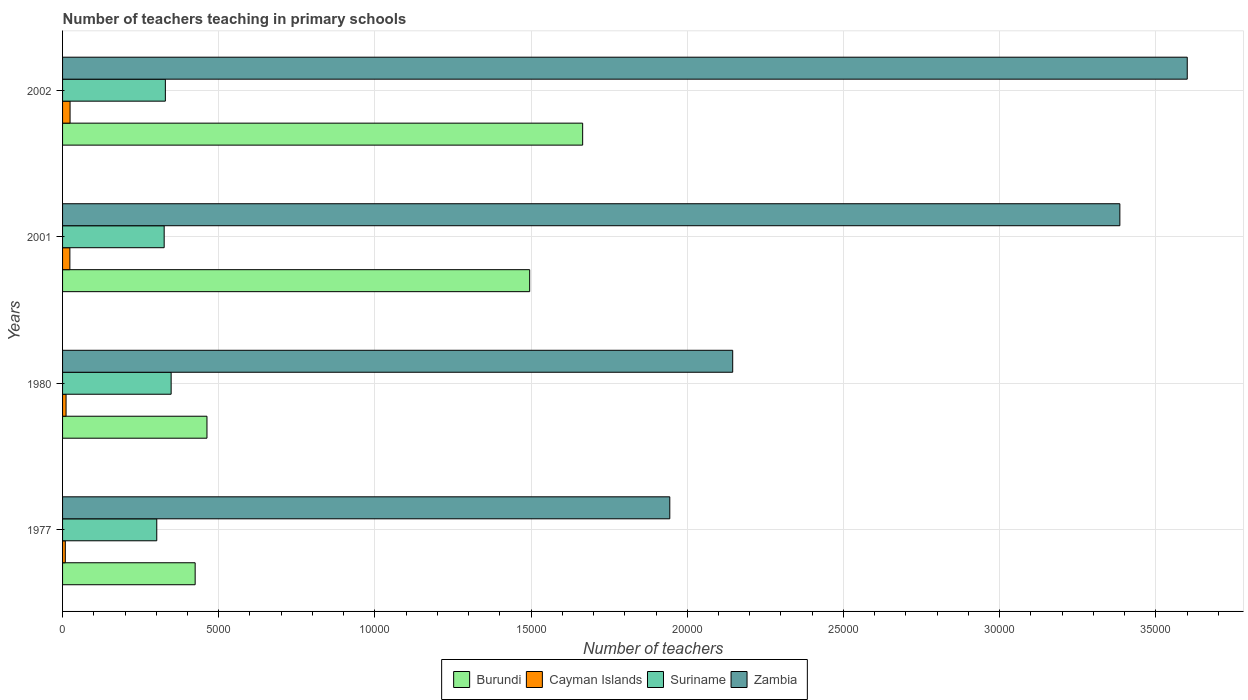How many groups of bars are there?
Keep it short and to the point. 4. Are the number of bars on each tick of the Y-axis equal?
Your answer should be compact. Yes. How many bars are there on the 1st tick from the bottom?
Keep it short and to the point. 4. What is the label of the 1st group of bars from the top?
Provide a succinct answer. 2002. What is the number of teachers teaching in primary schools in Zambia in 1977?
Your response must be concise. 1.94e+04. Across all years, what is the maximum number of teachers teaching in primary schools in Cayman Islands?
Make the answer very short. 240. Across all years, what is the minimum number of teachers teaching in primary schools in Suriname?
Offer a very short reply. 3016. In which year was the number of teachers teaching in primary schools in Suriname minimum?
Ensure brevity in your answer.  1977. What is the total number of teachers teaching in primary schools in Burundi in the graph?
Your response must be concise. 4.05e+04. What is the difference between the number of teachers teaching in primary schools in Burundi in 2001 and that in 2002?
Provide a short and direct response. -1696. What is the difference between the number of teachers teaching in primary schools in Burundi in 1980 and the number of teachers teaching in primary schools in Suriname in 1977?
Your response must be concise. 1607. What is the average number of teachers teaching in primary schools in Burundi per year?
Ensure brevity in your answer.  1.01e+04. In the year 2001, what is the difference between the number of teachers teaching in primary schools in Burundi and number of teachers teaching in primary schools in Suriname?
Offer a very short reply. 1.17e+04. What is the ratio of the number of teachers teaching in primary schools in Zambia in 1977 to that in 1980?
Make the answer very short. 0.91. Is the difference between the number of teachers teaching in primary schools in Burundi in 1977 and 1980 greater than the difference between the number of teachers teaching in primary schools in Suriname in 1977 and 1980?
Your answer should be very brief. Yes. What is the difference between the highest and the second highest number of teachers teaching in primary schools in Suriname?
Your answer should be compact. 185. What is the difference between the highest and the lowest number of teachers teaching in primary schools in Cayman Islands?
Provide a short and direct response. 152. In how many years, is the number of teachers teaching in primary schools in Burundi greater than the average number of teachers teaching in primary schools in Burundi taken over all years?
Offer a terse response. 2. Is it the case that in every year, the sum of the number of teachers teaching in primary schools in Cayman Islands and number of teachers teaching in primary schools in Zambia is greater than the sum of number of teachers teaching in primary schools in Suriname and number of teachers teaching in primary schools in Burundi?
Provide a succinct answer. Yes. What does the 4th bar from the top in 2002 represents?
Keep it short and to the point. Burundi. What does the 2nd bar from the bottom in 2001 represents?
Your answer should be compact. Cayman Islands. Is it the case that in every year, the sum of the number of teachers teaching in primary schools in Zambia and number of teachers teaching in primary schools in Cayman Islands is greater than the number of teachers teaching in primary schools in Suriname?
Your answer should be very brief. Yes. Does the graph contain grids?
Make the answer very short. Yes. Where does the legend appear in the graph?
Your answer should be very brief. Bottom center. How are the legend labels stacked?
Provide a short and direct response. Horizontal. What is the title of the graph?
Provide a succinct answer. Number of teachers teaching in primary schools. What is the label or title of the X-axis?
Offer a very short reply. Number of teachers. What is the label or title of the Y-axis?
Offer a terse response. Years. What is the Number of teachers of Burundi in 1977?
Your answer should be compact. 4245. What is the Number of teachers in Cayman Islands in 1977?
Give a very brief answer. 88. What is the Number of teachers of Suriname in 1977?
Offer a terse response. 3016. What is the Number of teachers of Zambia in 1977?
Provide a short and direct response. 1.94e+04. What is the Number of teachers of Burundi in 1980?
Keep it short and to the point. 4623. What is the Number of teachers of Cayman Islands in 1980?
Offer a terse response. 112. What is the Number of teachers in Suriname in 1980?
Give a very brief answer. 3476. What is the Number of teachers of Zambia in 1980?
Your answer should be very brief. 2.15e+04. What is the Number of teachers in Burundi in 2001?
Keep it short and to the point. 1.50e+04. What is the Number of teachers in Cayman Islands in 2001?
Give a very brief answer. 234. What is the Number of teachers of Suriname in 2001?
Your answer should be compact. 3253. What is the Number of teachers in Zambia in 2001?
Offer a terse response. 3.38e+04. What is the Number of teachers of Burundi in 2002?
Provide a short and direct response. 1.67e+04. What is the Number of teachers in Cayman Islands in 2002?
Make the answer very short. 240. What is the Number of teachers of Suriname in 2002?
Ensure brevity in your answer.  3291. What is the Number of teachers of Zambia in 2002?
Your answer should be very brief. 3.60e+04. Across all years, what is the maximum Number of teachers in Burundi?
Make the answer very short. 1.67e+04. Across all years, what is the maximum Number of teachers in Cayman Islands?
Provide a succinct answer. 240. Across all years, what is the maximum Number of teachers in Suriname?
Keep it short and to the point. 3476. Across all years, what is the maximum Number of teachers in Zambia?
Keep it short and to the point. 3.60e+04. Across all years, what is the minimum Number of teachers of Burundi?
Provide a succinct answer. 4245. Across all years, what is the minimum Number of teachers in Suriname?
Give a very brief answer. 3016. Across all years, what is the minimum Number of teachers in Zambia?
Your response must be concise. 1.94e+04. What is the total Number of teachers of Burundi in the graph?
Keep it short and to the point. 4.05e+04. What is the total Number of teachers in Cayman Islands in the graph?
Your response must be concise. 674. What is the total Number of teachers in Suriname in the graph?
Keep it short and to the point. 1.30e+04. What is the total Number of teachers of Zambia in the graph?
Offer a very short reply. 1.11e+05. What is the difference between the Number of teachers in Burundi in 1977 and that in 1980?
Provide a succinct answer. -378. What is the difference between the Number of teachers of Suriname in 1977 and that in 1980?
Offer a very short reply. -460. What is the difference between the Number of teachers in Zambia in 1977 and that in 1980?
Give a very brief answer. -2014. What is the difference between the Number of teachers in Burundi in 1977 and that in 2001?
Provide a succinct answer. -1.07e+04. What is the difference between the Number of teachers of Cayman Islands in 1977 and that in 2001?
Your response must be concise. -146. What is the difference between the Number of teachers in Suriname in 1977 and that in 2001?
Your response must be concise. -237. What is the difference between the Number of teachers of Zambia in 1977 and that in 2001?
Your answer should be compact. -1.44e+04. What is the difference between the Number of teachers of Burundi in 1977 and that in 2002?
Make the answer very short. -1.24e+04. What is the difference between the Number of teachers of Cayman Islands in 1977 and that in 2002?
Your answer should be very brief. -152. What is the difference between the Number of teachers of Suriname in 1977 and that in 2002?
Make the answer very short. -275. What is the difference between the Number of teachers in Zambia in 1977 and that in 2002?
Offer a terse response. -1.66e+04. What is the difference between the Number of teachers of Burundi in 1980 and that in 2001?
Ensure brevity in your answer.  -1.03e+04. What is the difference between the Number of teachers of Cayman Islands in 1980 and that in 2001?
Offer a terse response. -122. What is the difference between the Number of teachers in Suriname in 1980 and that in 2001?
Provide a short and direct response. 223. What is the difference between the Number of teachers of Zambia in 1980 and that in 2001?
Ensure brevity in your answer.  -1.24e+04. What is the difference between the Number of teachers of Burundi in 1980 and that in 2002?
Offer a terse response. -1.20e+04. What is the difference between the Number of teachers in Cayman Islands in 1980 and that in 2002?
Ensure brevity in your answer.  -128. What is the difference between the Number of teachers in Suriname in 1980 and that in 2002?
Your answer should be compact. 185. What is the difference between the Number of teachers of Zambia in 1980 and that in 2002?
Give a very brief answer. -1.46e+04. What is the difference between the Number of teachers of Burundi in 2001 and that in 2002?
Ensure brevity in your answer.  -1696. What is the difference between the Number of teachers in Suriname in 2001 and that in 2002?
Make the answer very short. -38. What is the difference between the Number of teachers in Zambia in 2001 and that in 2002?
Your answer should be very brief. -2158. What is the difference between the Number of teachers in Burundi in 1977 and the Number of teachers in Cayman Islands in 1980?
Your answer should be very brief. 4133. What is the difference between the Number of teachers in Burundi in 1977 and the Number of teachers in Suriname in 1980?
Keep it short and to the point. 769. What is the difference between the Number of teachers of Burundi in 1977 and the Number of teachers of Zambia in 1980?
Offer a very short reply. -1.72e+04. What is the difference between the Number of teachers in Cayman Islands in 1977 and the Number of teachers in Suriname in 1980?
Make the answer very short. -3388. What is the difference between the Number of teachers of Cayman Islands in 1977 and the Number of teachers of Zambia in 1980?
Your answer should be very brief. -2.14e+04. What is the difference between the Number of teachers of Suriname in 1977 and the Number of teachers of Zambia in 1980?
Make the answer very short. -1.84e+04. What is the difference between the Number of teachers of Burundi in 1977 and the Number of teachers of Cayman Islands in 2001?
Your response must be concise. 4011. What is the difference between the Number of teachers in Burundi in 1977 and the Number of teachers in Suriname in 2001?
Keep it short and to the point. 992. What is the difference between the Number of teachers in Burundi in 1977 and the Number of teachers in Zambia in 2001?
Your response must be concise. -2.96e+04. What is the difference between the Number of teachers of Cayman Islands in 1977 and the Number of teachers of Suriname in 2001?
Ensure brevity in your answer.  -3165. What is the difference between the Number of teachers of Cayman Islands in 1977 and the Number of teachers of Zambia in 2001?
Your answer should be compact. -3.38e+04. What is the difference between the Number of teachers in Suriname in 1977 and the Number of teachers in Zambia in 2001?
Your answer should be compact. -3.08e+04. What is the difference between the Number of teachers in Burundi in 1977 and the Number of teachers in Cayman Islands in 2002?
Give a very brief answer. 4005. What is the difference between the Number of teachers in Burundi in 1977 and the Number of teachers in Suriname in 2002?
Provide a short and direct response. 954. What is the difference between the Number of teachers of Burundi in 1977 and the Number of teachers of Zambia in 2002?
Give a very brief answer. -3.18e+04. What is the difference between the Number of teachers in Cayman Islands in 1977 and the Number of teachers in Suriname in 2002?
Keep it short and to the point. -3203. What is the difference between the Number of teachers of Cayman Islands in 1977 and the Number of teachers of Zambia in 2002?
Make the answer very short. -3.59e+04. What is the difference between the Number of teachers in Suriname in 1977 and the Number of teachers in Zambia in 2002?
Your answer should be very brief. -3.30e+04. What is the difference between the Number of teachers of Burundi in 1980 and the Number of teachers of Cayman Islands in 2001?
Provide a short and direct response. 4389. What is the difference between the Number of teachers in Burundi in 1980 and the Number of teachers in Suriname in 2001?
Your answer should be very brief. 1370. What is the difference between the Number of teachers in Burundi in 1980 and the Number of teachers in Zambia in 2001?
Your answer should be compact. -2.92e+04. What is the difference between the Number of teachers in Cayman Islands in 1980 and the Number of teachers in Suriname in 2001?
Keep it short and to the point. -3141. What is the difference between the Number of teachers of Cayman Islands in 1980 and the Number of teachers of Zambia in 2001?
Ensure brevity in your answer.  -3.37e+04. What is the difference between the Number of teachers in Suriname in 1980 and the Number of teachers in Zambia in 2001?
Ensure brevity in your answer.  -3.04e+04. What is the difference between the Number of teachers of Burundi in 1980 and the Number of teachers of Cayman Islands in 2002?
Provide a succinct answer. 4383. What is the difference between the Number of teachers of Burundi in 1980 and the Number of teachers of Suriname in 2002?
Provide a short and direct response. 1332. What is the difference between the Number of teachers in Burundi in 1980 and the Number of teachers in Zambia in 2002?
Keep it short and to the point. -3.14e+04. What is the difference between the Number of teachers in Cayman Islands in 1980 and the Number of teachers in Suriname in 2002?
Provide a succinct answer. -3179. What is the difference between the Number of teachers in Cayman Islands in 1980 and the Number of teachers in Zambia in 2002?
Give a very brief answer. -3.59e+04. What is the difference between the Number of teachers in Suriname in 1980 and the Number of teachers in Zambia in 2002?
Keep it short and to the point. -3.25e+04. What is the difference between the Number of teachers in Burundi in 2001 and the Number of teachers in Cayman Islands in 2002?
Your response must be concise. 1.47e+04. What is the difference between the Number of teachers in Burundi in 2001 and the Number of teachers in Suriname in 2002?
Offer a very short reply. 1.17e+04. What is the difference between the Number of teachers in Burundi in 2001 and the Number of teachers in Zambia in 2002?
Your response must be concise. -2.11e+04. What is the difference between the Number of teachers of Cayman Islands in 2001 and the Number of teachers of Suriname in 2002?
Your answer should be compact. -3057. What is the difference between the Number of teachers of Cayman Islands in 2001 and the Number of teachers of Zambia in 2002?
Offer a very short reply. -3.58e+04. What is the difference between the Number of teachers of Suriname in 2001 and the Number of teachers of Zambia in 2002?
Give a very brief answer. -3.28e+04. What is the average Number of teachers in Burundi per year?
Provide a short and direct response. 1.01e+04. What is the average Number of teachers in Cayman Islands per year?
Ensure brevity in your answer.  168.5. What is the average Number of teachers of Suriname per year?
Provide a short and direct response. 3259. What is the average Number of teachers of Zambia per year?
Your response must be concise. 2.77e+04. In the year 1977, what is the difference between the Number of teachers of Burundi and Number of teachers of Cayman Islands?
Provide a short and direct response. 4157. In the year 1977, what is the difference between the Number of teachers in Burundi and Number of teachers in Suriname?
Ensure brevity in your answer.  1229. In the year 1977, what is the difference between the Number of teachers in Burundi and Number of teachers in Zambia?
Offer a very short reply. -1.52e+04. In the year 1977, what is the difference between the Number of teachers in Cayman Islands and Number of teachers in Suriname?
Give a very brief answer. -2928. In the year 1977, what is the difference between the Number of teachers in Cayman Islands and Number of teachers in Zambia?
Your answer should be compact. -1.94e+04. In the year 1977, what is the difference between the Number of teachers in Suriname and Number of teachers in Zambia?
Ensure brevity in your answer.  -1.64e+04. In the year 1980, what is the difference between the Number of teachers of Burundi and Number of teachers of Cayman Islands?
Ensure brevity in your answer.  4511. In the year 1980, what is the difference between the Number of teachers of Burundi and Number of teachers of Suriname?
Your response must be concise. 1147. In the year 1980, what is the difference between the Number of teachers of Burundi and Number of teachers of Zambia?
Provide a succinct answer. -1.68e+04. In the year 1980, what is the difference between the Number of teachers in Cayman Islands and Number of teachers in Suriname?
Keep it short and to the point. -3364. In the year 1980, what is the difference between the Number of teachers in Cayman Islands and Number of teachers in Zambia?
Your answer should be very brief. -2.13e+04. In the year 1980, what is the difference between the Number of teachers in Suriname and Number of teachers in Zambia?
Offer a very short reply. -1.80e+04. In the year 2001, what is the difference between the Number of teachers in Burundi and Number of teachers in Cayman Islands?
Keep it short and to the point. 1.47e+04. In the year 2001, what is the difference between the Number of teachers in Burundi and Number of teachers in Suriname?
Offer a terse response. 1.17e+04. In the year 2001, what is the difference between the Number of teachers of Burundi and Number of teachers of Zambia?
Provide a short and direct response. -1.89e+04. In the year 2001, what is the difference between the Number of teachers of Cayman Islands and Number of teachers of Suriname?
Your answer should be compact. -3019. In the year 2001, what is the difference between the Number of teachers of Cayman Islands and Number of teachers of Zambia?
Provide a succinct answer. -3.36e+04. In the year 2001, what is the difference between the Number of teachers in Suriname and Number of teachers in Zambia?
Your answer should be compact. -3.06e+04. In the year 2002, what is the difference between the Number of teachers of Burundi and Number of teachers of Cayman Islands?
Make the answer very short. 1.64e+04. In the year 2002, what is the difference between the Number of teachers of Burundi and Number of teachers of Suriname?
Offer a terse response. 1.34e+04. In the year 2002, what is the difference between the Number of teachers in Burundi and Number of teachers in Zambia?
Your answer should be compact. -1.94e+04. In the year 2002, what is the difference between the Number of teachers in Cayman Islands and Number of teachers in Suriname?
Provide a succinct answer. -3051. In the year 2002, what is the difference between the Number of teachers of Cayman Islands and Number of teachers of Zambia?
Offer a terse response. -3.58e+04. In the year 2002, what is the difference between the Number of teachers of Suriname and Number of teachers of Zambia?
Provide a succinct answer. -3.27e+04. What is the ratio of the Number of teachers in Burundi in 1977 to that in 1980?
Keep it short and to the point. 0.92. What is the ratio of the Number of teachers in Cayman Islands in 1977 to that in 1980?
Your response must be concise. 0.79. What is the ratio of the Number of teachers in Suriname in 1977 to that in 1980?
Your response must be concise. 0.87. What is the ratio of the Number of teachers in Zambia in 1977 to that in 1980?
Provide a short and direct response. 0.91. What is the ratio of the Number of teachers of Burundi in 1977 to that in 2001?
Provide a succinct answer. 0.28. What is the ratio of the Number of teachers of Cayman Islands in 1977 to that in 2001?
Keep it short and to the point. 0.38. What is the ratio of the Number of teachers in Suriname in 1977 to that in 2001?
Your response must be concise. 0.93. What is the ratio of the Number of teachers in Zambia in 1977 to that in 2001?
Offer a very short reply. 0.57. What is the ratio of the Number of teachers in Burundi in 1977 to that in 2002?
Your response must be concise. 0.25. What is the ratio of the Number of teachers of Cayman Islands in 1977 to that in 2002?
Make the answer very short. 0.37. What is the ratio of the Number of teachers in Suriname in 1977 to that in 2002?
Provide a short and direct response. 0.92. What is the ratio of the Number of teachers of Zambia in 1977 to that in 2002?
Give a very brief answer. 0.54. What is the ratio of the Number of teachers of Burundi in 1980 to that in 2001?
Ensure brevity in your answer.  0.31. What is the ratio of the Number of teachers in Cayman Islands in 1980 to that in 2001?
Make the answer very short. 0.48. What is the ratio of the Number of teachers of Suriname in 1980 to that in 2001?
Your response must be concise. 1.07. What is the ratio of the Number of teachers in Zambia in 1980 to that in 2001?
Your answer should be very brief. 0.63. What is the ratio of the Number of teachers in Burundi in 1980 to that in 2002?
Make the answer very short. 0.28. What is the ratio of the Number of teachers of Cayman Islands in 1980 to that in 2002?
Your answer should be compact. 0.47. What is the ratio of the Number of teachers in Suriname in 1980 to that in 2002?
Give a very brief answer. 1.06. What is the ratio of the Number of teachers of Zambia in 1980 to that in 2002?
Make the answer very short. 0.6. What is the ratio of the Number of teachers of Burundi in 2001 to that in 2002?
Keep it short and to the point. 0.9. What is the ratio of the Number of teachers in Zambia in 2001 to that in 2002?
Give a very brief answer. 0.94. What is the difference between the highest and the second highest Number of teachers in Burundi?
Make the answer very short. 1696. What is the difference between the highest and the second highest Number of teachers of Suriname?
Keep it short and to the point. 185. What is the difference between the highest and the second highest Number of teachers in Zambia?
Offer a very short reply. 2158. What is the difference between the highest and the lowest Number of teachers of Burundi?
Your answer should be very brief. 1.24e+04. What is the difference between the highest and the lowest Number of teachers of Cayman Islands?
Provide a short and direct response. 152. What is the difference between the highest and the lowest Number of teachers of Suriname?
Provide a short and direct response. 460. What is the difference between the highest and the lowest Number of teachers of Zambia?
Provide a short and direct response. 1.66e+04. 